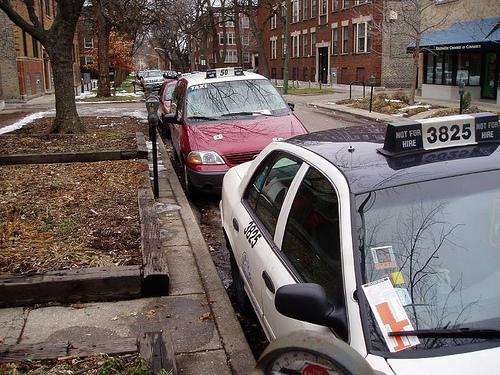Describe the setting and atmosphere of the image. The image showcases a city street with a row of cars parked along the sidewalk and red brick buildings across the street. What is the significance of the grassy squares in the image? The grassy squares bring a touch of nature to the city environment by offering bordered areas of soil and grass. Mention an uncommon visual detail in the image. There's a reflection on the white taxi's windshield that is worth noticing. Portray what the cars are doing on the side of the road. The cars are parked on the side of the road, with some of them displaying parking tickets on their windshields. Describe the color and architectural style of the buildings in the image. The image features red brick buildings with stone sides that are of traditional city architecture. Identify the main mode of transportation featured in the image. The main mode of transportation is taxis parked on the side of the road. Name one primary color visible in multiple objects and mention those objects. Red is a primary color visible in the red taxi cab, the red and white taxi van, and the red brick buildings. What is one important aspect of the image related to parking? A significant aspect of the image related to parking is the presence of a gray and black parking meter on the street. Mention one unique aspect of the image. A white car has black numbers on it, which is a taxi parked on the street. Describe the relationship between the walking path and the other elements in the image. The walking path is positioned in between two boards, alongside grassy squares, parked cars, and a red brick building with stone sides. 